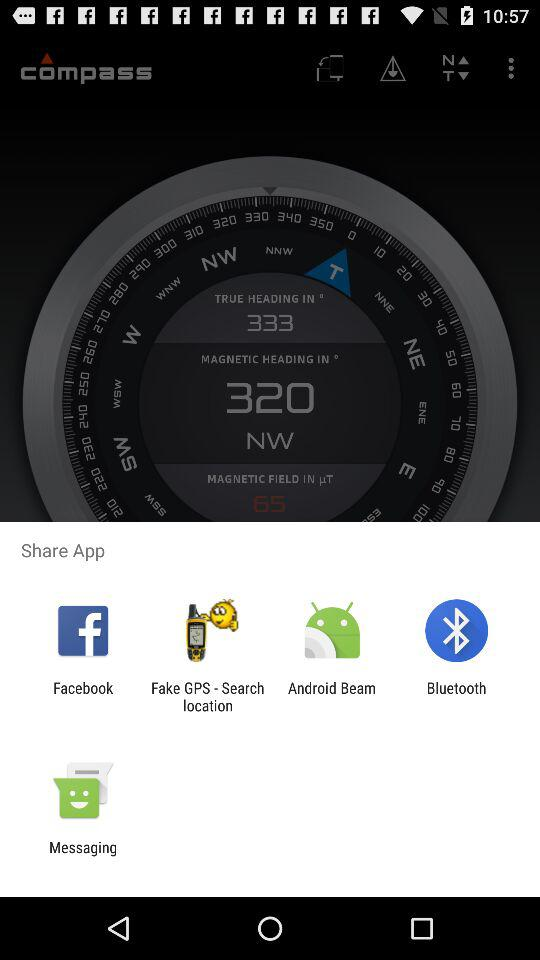What is the name of the application? The name of the application is "compass". 